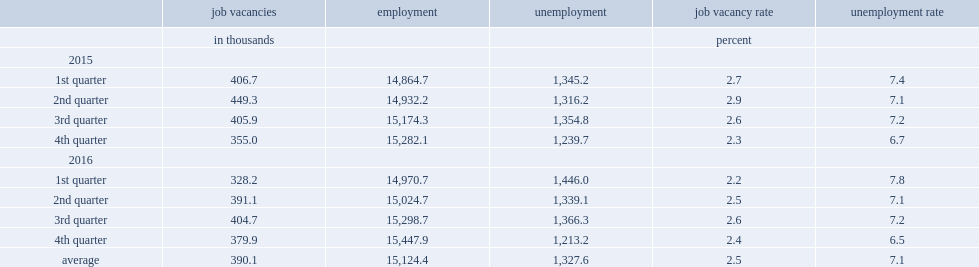In the two-year period from january 2015 to december 2016, how many thousands of the average of unemployed persons in canada? 1327.6. In the two-year period from january 2015 to december 2016, how many thousands of the average of job vacancies in canada? 390.1. 